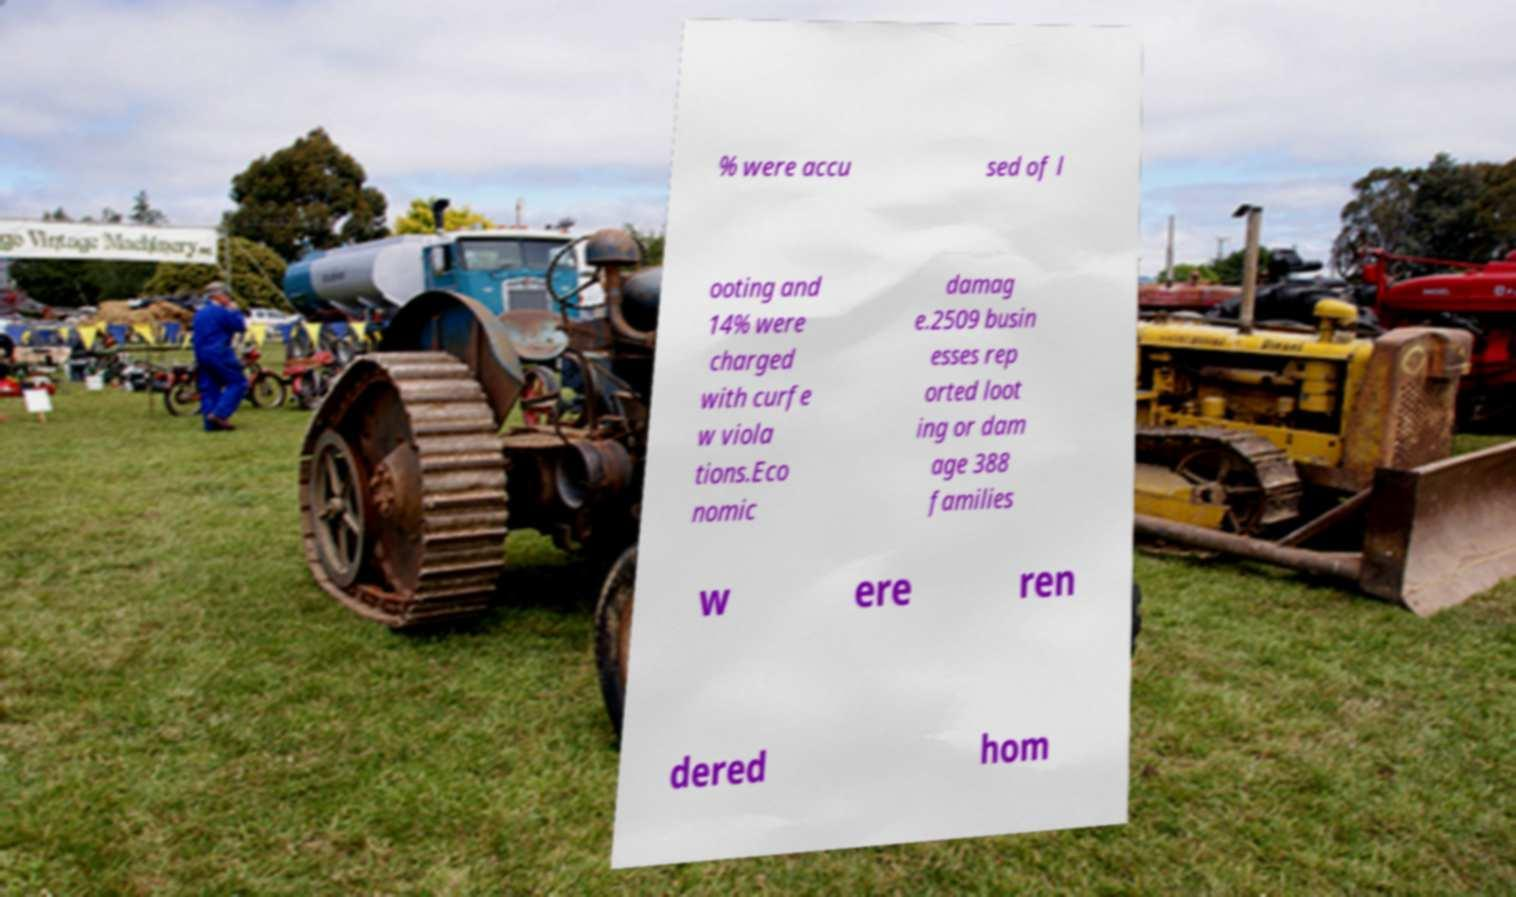What messages or text are displayed in this image? I need them in a readable, typed format. % were accu sed of l ooting and 14% were charged with curfe w viola tions.Eco nomic damag e.2509 busin esses rep orted loot ing or dam age 388 families w ere ren dered hom 